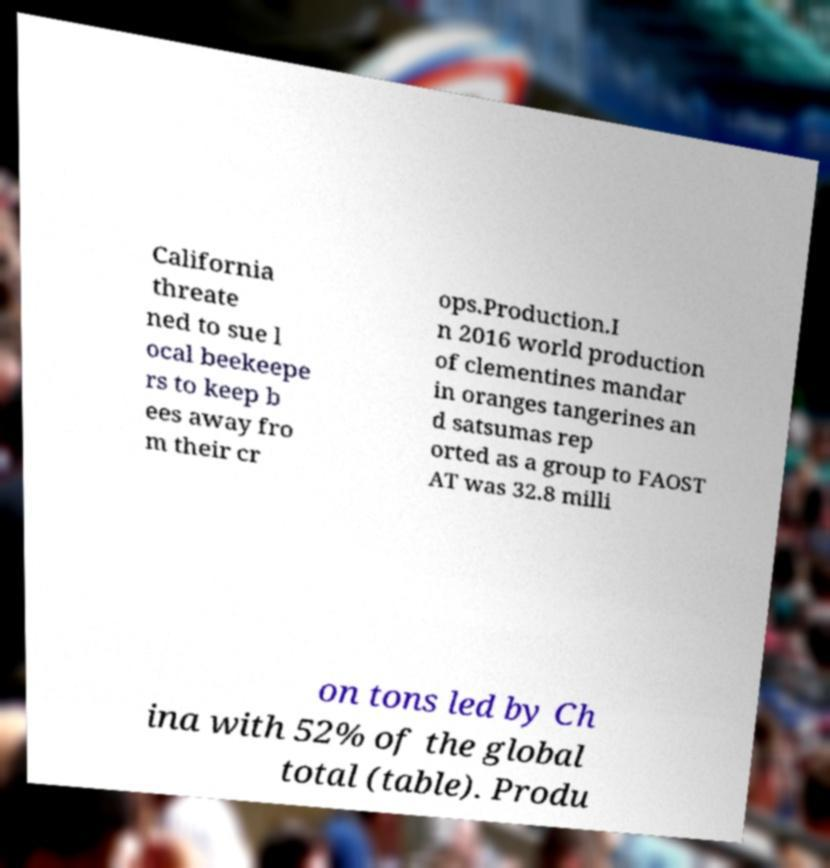Can you accurately transcribe the text from the provided image for me? California threate ned to sue l ocal beekeepe rs to keep b ees away fro m their cr ops.Production.I n 2016 world production of clementines mandar in oranges tangerines an d satsumas rep orted as a group to FAOST AT was 32.8 milli on tons led by Ch ina with 52% of the global total (table). Produ 